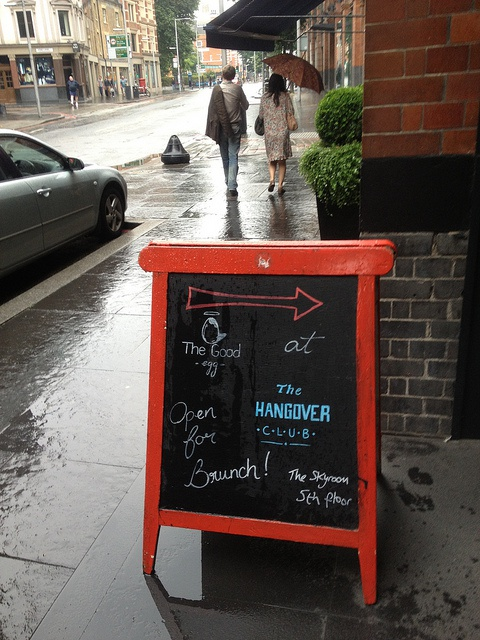Describe the objects in this image and their specific colors. I can see car in white, black, gray, and darkgray tones, potted plant in white, black, darkgreen, and olive tones, people in ivory, gray, black, and darkgray tones, people in white, gray, black, and darkgray tones, and umbrella in white, maroon, black, brown, and gray tones in this image. 